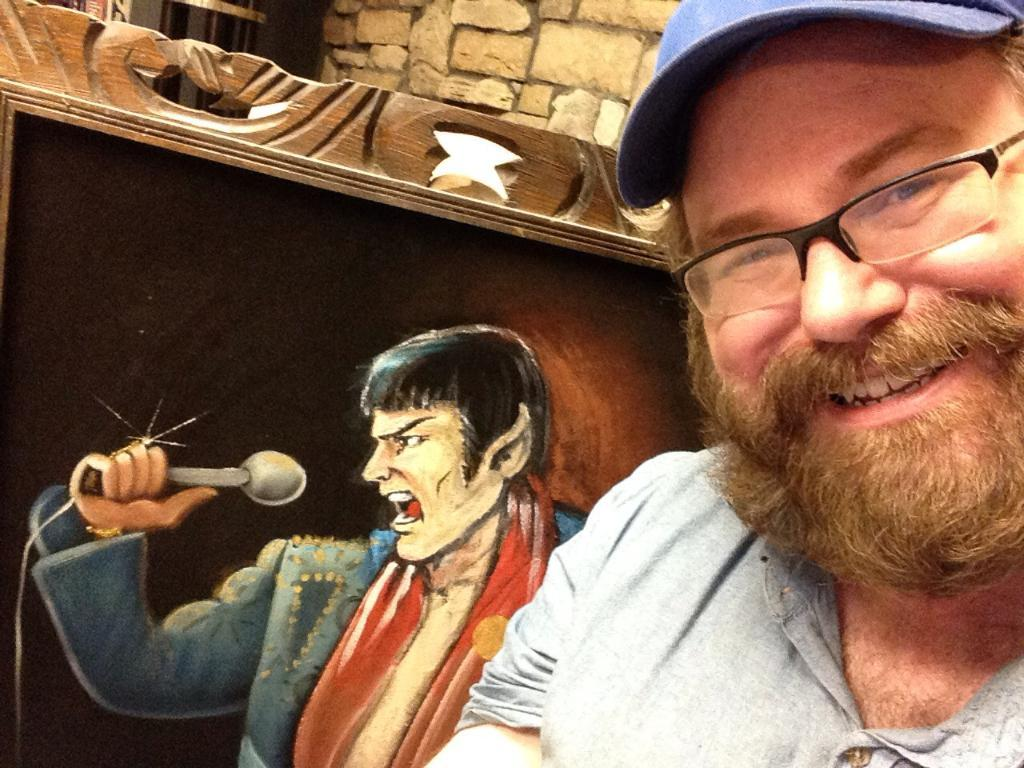What is the main subject of the image? The main subject of the image is a man. Can you describe the man's appearance? The man is wearing glasses and a cap. What is the man's facial expression? The man is smiling. What can be seen in the background of the image? There is a wall in the background of the image. Is there any other person visible in the image? There is a frame of a person's (possibly the man's) in the image. What type of bean is being distributed for breakfast in the image? There is no bean or breakfast scene present in the image; it features a man wearing glasses and a cap, smiling, and standing in front of a wall. 